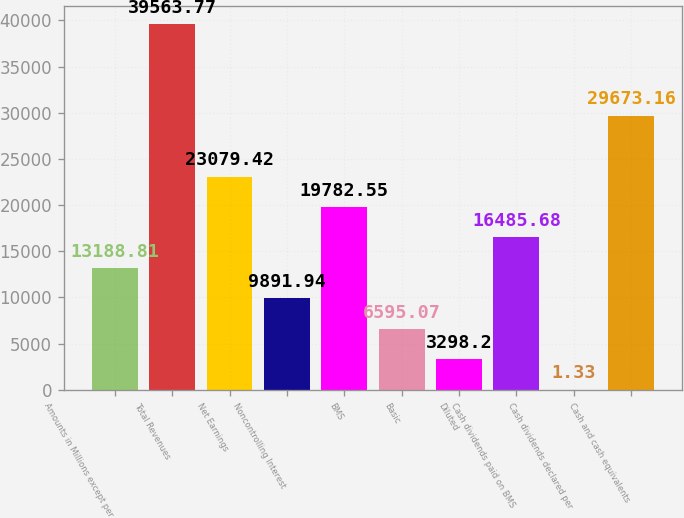<chart> <loc_0><loc_0><loc_500><loc_500><bar_chart><fcel>Amounts in Millions except per<fcel>Total Revenues<fcel>Net Earnings<fcel>Noncontrolling Interest<fcel>BMS<fcel>Basic<fcel>Diluted<fcel>Cash dividends paid on BMS<fcel>Cash dividends declared per<fcel>Cash and cash equivalents<nl><fcel>13188.8<fcel>39563.8<fcel>23079.4<fcel>9891.94<fcel>19782.5<fcel>6595.07<fcel>3298.2<fcel>16485.7<fcel>1.33<fcel>29673.2<nl></chart> 